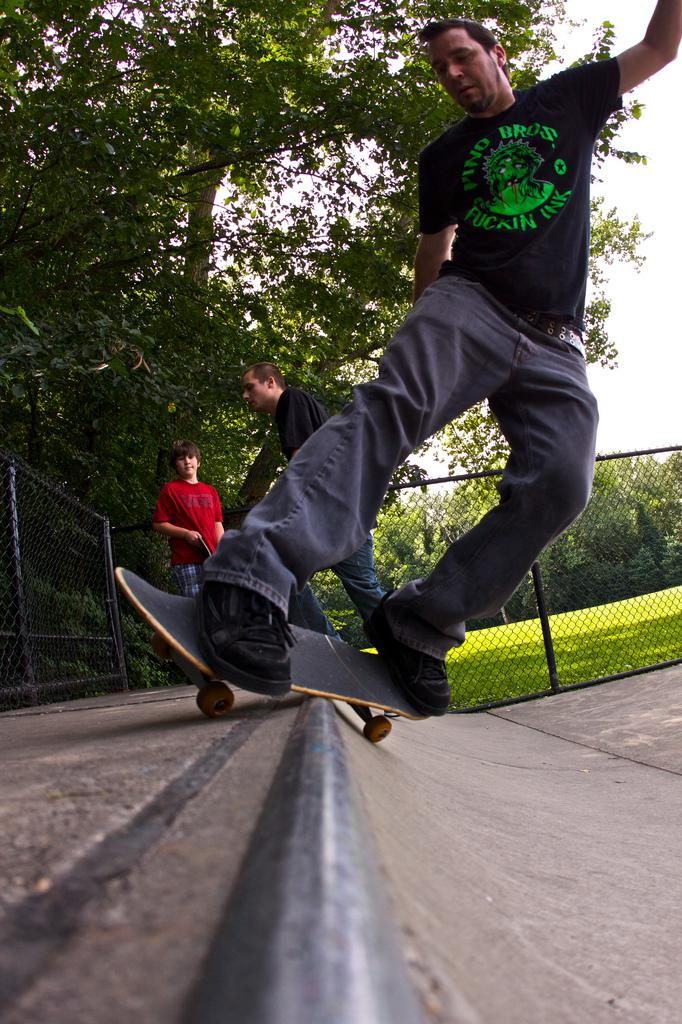Question: what is green?
Choices:
A. Grass.
B. A hat.
C. Shoes.
D. Writing on shirt.
Answer with the letter. Answer: D Question: what is tilted?
Choices:
A. Man's skateboard.
B. The Man's head.
C. The dog's head.
D. The polar axis.
Answer with the letter. Answer: A Question: what has profanity on it?
Choices:
A. Man's hat.
B. Man's sign.
C. Man's shirt.
D. Fence.
Answer with the letter. Answer: C Question: what sort of plane does this photo show?
Choices:
A. An inclined plane.
B. A small one.
C. A crashed one.
D. A new one.
Answer with the letter. Answer: A Question: what is the man in the front doing?
Choices:
A. Skateboarding.
B. Walking.
C. Running.
D. Cycling.
Answer with the letter. Answer: A Question: what sport are they practicing?
Choices:
A. Soccer.
B. Skateboarding.
C. Basketball.
D. Baseball.
Answer with the letter. Answer: B Question: what is the park bound with?
Choices:
A. A wooden fence.
B. A picket fence.
C. A brick wall.
D. Chain link fence.
Answer with the letter. Answer: D Question: who is in the picture?
Choices:
A. A clown.
B. Skateboarder.
C. A magician.
D. My family.
Answer with the letter. Answer: B Question: what type of day is it?
Choices:
A. Rainy.
B. Cloudy.
C. Clear.
D. Sunny.
Answer with the letter. Answer: D Question: why does the man in front have his arm up?
Choices:
A. To catch something.
B. To wave.
C. To throw something.
D. For balance.
Answer with the letter. Answer: D Question: where does this picture take place?
Choices:
A. Skate park.
B. Nature trail.
C. Forest.
D. Lake.
Answer with the letter. Answer: A Question: how many people are in the picture?
Choices:
A. Four.
B. Five.
C. Six.
D. Three.
Answer with the letter. Answer: D Question: where is he skating?
Choices:
A. An ice rink.
B. Down the hill.
C. Skatepark.
D. Under the bridge.
Answer with the letter. Answer: C Question: where was the photo taken?
Choices:
A. A park.
B. A forest.
C. A jungle.
D. A riverside.
Answer with the letter. Answer: A Question: who is wearing plaid shorts?
Choices:
A. The boy.
B. The girl.
C. The woman.
D. The man.
Answer with the letter. Answer: A Question: who is wearing a red shirt?
Choices:
A. The waiter.
B. The coach.
C. A man.
D. A boy.
Answer with the letter. Answer: D Question: what is in the background?
Choices:
A. A statue.
B. An elephant.
C. A dog.
D. Large trees.
Answer with the letter. Answer: D Question: where is the chain link fence?
Choices:
A. Around the baseball field.
B. Around the school yard.
C. At the dog pound.
D. Behind the people.
Answer with the letter. Answer: D Question: what is very green?
Choices:
A. The shirt I have to wear everyday to work.
B. Mint leaves.
C. Beer on St Patrick's day.
D. Grass in background.
Answer with the letter. Answer: D Question: what is overcast?
Choices:
A. Overhead.
B. Up.
C. Atmosphere.
D. Sky.
Answer with the letter. Answer: D Question: what is black?
Choices:
A. Planks.
B. Wood.
C. Fencing.
D. Metal.
Answer with the letter. Answer: C 